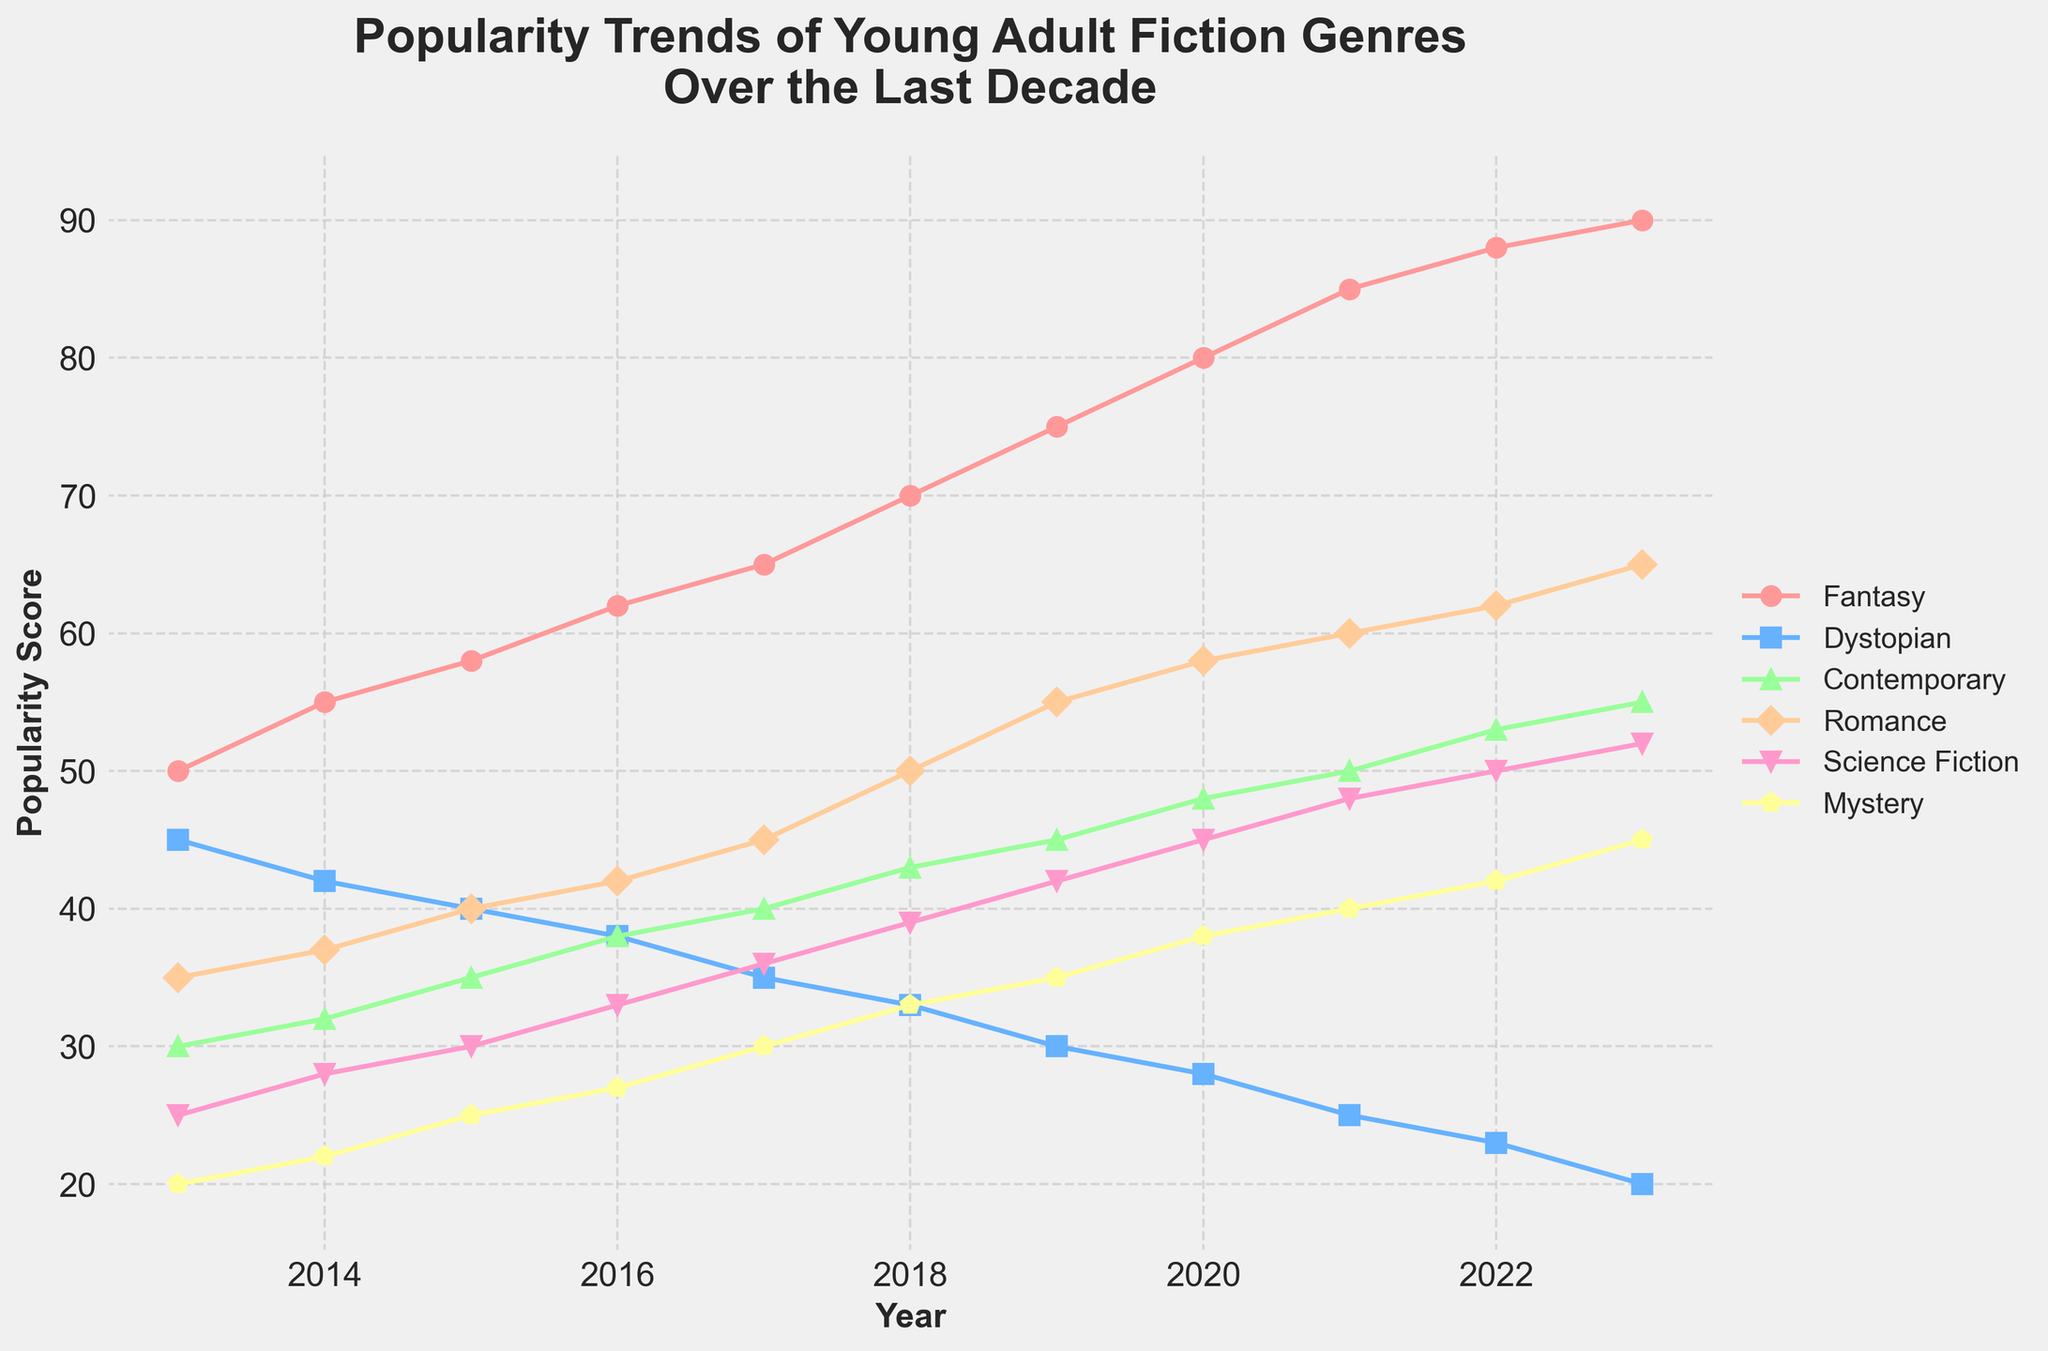What is the title of the figure? The title of a figure is usually displayed prominently at the top. In this figure, it is "Popularity Trends of Young Adult Fiction Genres Over the Last Decade".
Answer: Popularity Trends of Young Adult Fiction Genres Over the Last Decade Which genre had the highest popularity in 2023? By observing the data points and their labels for 2023, we can see that 'Fantasy' has the highest popularity score at 90.
Answer: Fantasy How many genres are tracked in the figure? The legend of the plot lists all the genres being tracked. Here, there are six genres: Fantasy, Dystopian, Contemporary, Romance, Science Fiction, and Mystery.
Answer: Six What was the popularity score of Romance in 2019? Locate the line corresponding to 'Romance' and find its data point for the year 2019. The score for Romance at this point is 55.
Answer: 55 Which genre's popularity decreased the most over the last decade? Comparing the starting and ending points for each genre, 'Dystopian' shows a significant decrease from 45 in 2013 to 20 in 2023.
Answer: Dystopian In which year did Contemporary first surpass Dystopian in popularity? By following the lines for 'Contemporary' and 'Dystopian', we see that Contemporary first surpasses Dystopian in 2016.
Answer: 2016 What is the general trend observed for Fantasy over the last decade? The 'Fantasy' line consistently trends upwards from 50 in 2013 to 90 in 2023, indicating an increasing trend in popularity.
Answer: Increasing Which genre maintained the most constant popularity throughout the decade? By examining the fluctuations in each line, 'Mystery' shows the least variation, growing steadily with small increments from 20 to 45.
Answer: Mystery What is the average popularity score of Science Fiction from 2013 to 2023? To calculate the average, find the sum of Science Fiction scores over the years (25 + 28 + 30 + 33 + 36 + 39 + 42 + 45 + 48 + 50 + 52) = 428, then divide by the number of years (11). The average is 428/11, approximately 38.91.
Answer: Approximately 38.91 